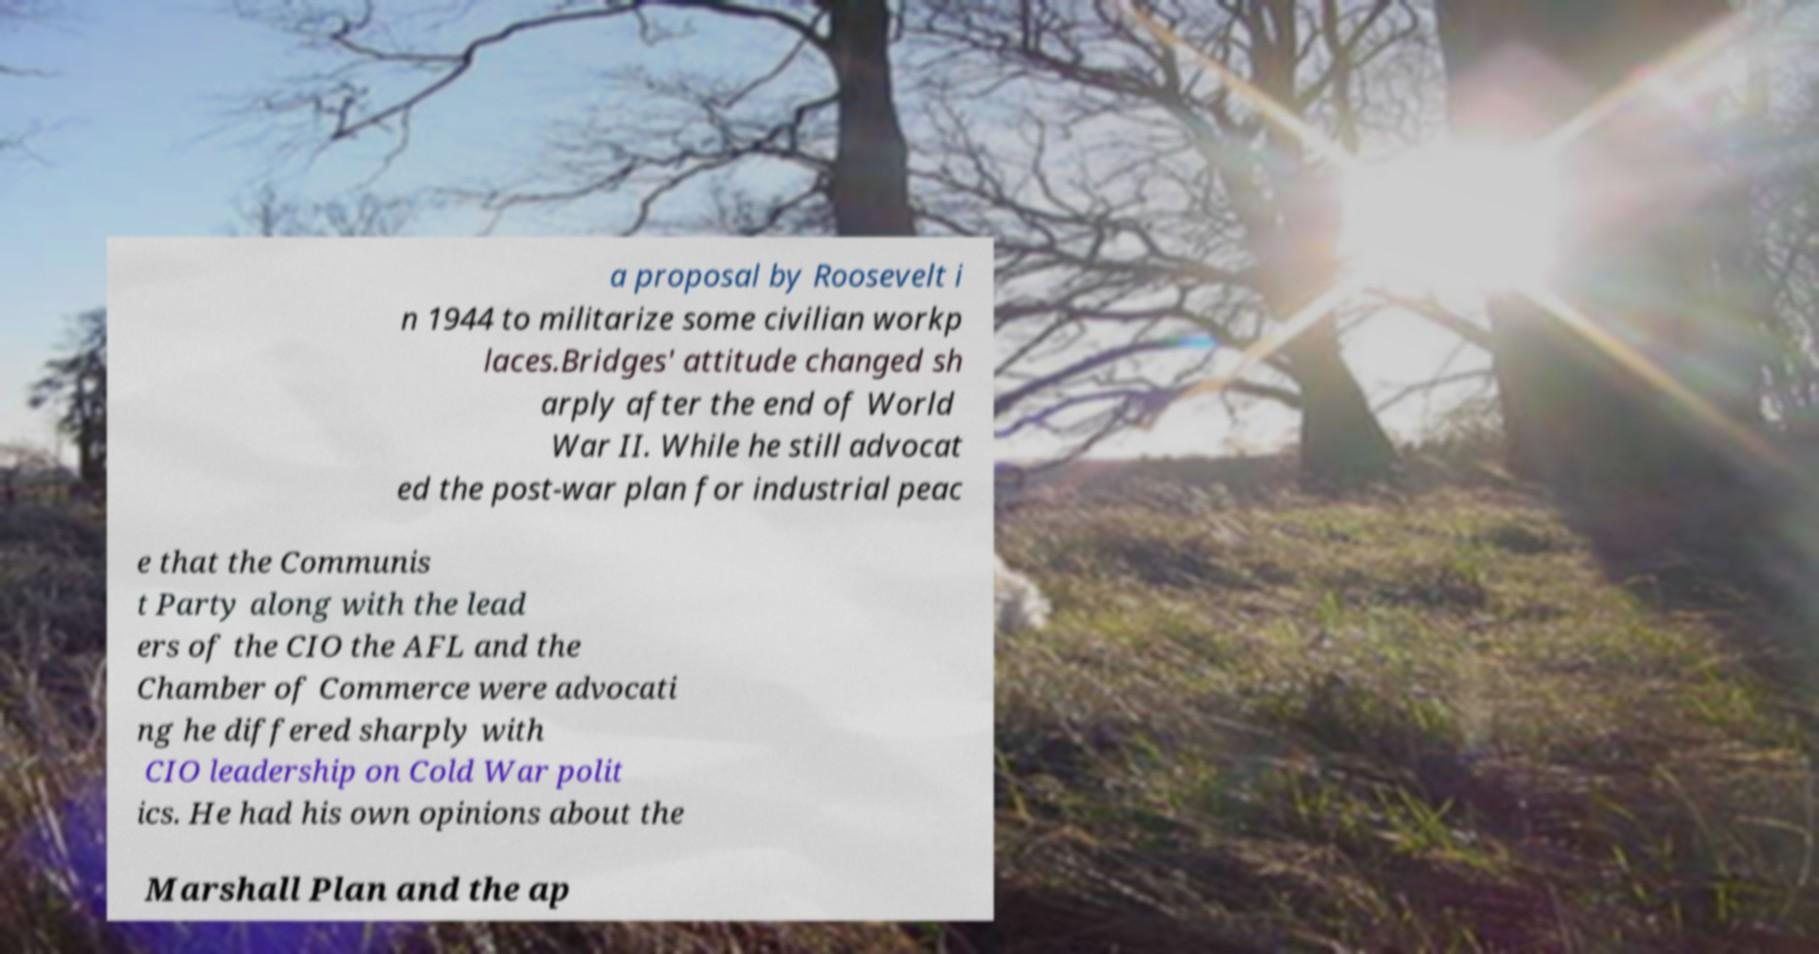I need the written content from this picture converted into text. Can you do that? a proposal by Roosevelt i n 1944 to militarize some civilian workp laces.Bridges' attitude changed sh arply after the end of World War II. While he still advocat ed the post-war plan for industrial peac e that the Communis t Party along with the lead ers of the CIO the AFL and the Chamber of Commerce were advocati ng he differed sharply with CIO leadership on Cold War polit ics. He had his own opinions about the Marshall Plan and the ap 